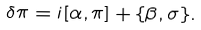Convert formula to latex. <formula><loc_0><loc_0><loc_500><loc_500>\delta \pi = i [ \alpha , \pi ] + \{ \beta , \sigma \} .</formula> 